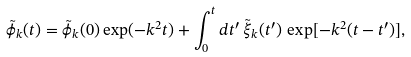Convert formula to latex. <formula><loc_0><loc_0><loc_500><loc_500>\tilde { \phi } _ { k } ( t ) = \tilde { \phi } _ { k } ( 0 ) \exp ( - k ^ { 2 } t ) + \int _ { 0 } ^ { t } d t ^ { \prime } \, \tilde { \xi } _ { k } ( t ^ { \prime } ) \, \exp [ - k ^ { 2 } ( t - t ^ { \prime } ) ] ,</formula> 